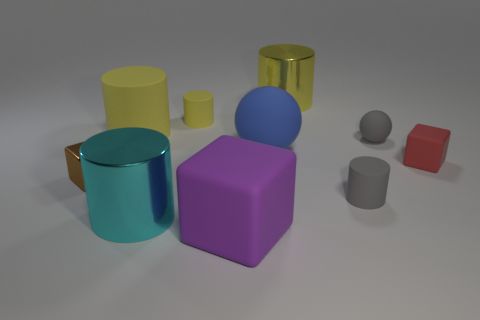Subtract all brown cubes. How many yellow cylinders are left? 3 Subtract all gray cylinders. How many cylinders are left? 4 Subtract all big matte cylinders. How many cylinders are left? 4 Subtract 2 cylinders. How many cylinders are left? 3 Subtract all blue cylinders. Subtract all brown balls. How many cylinders are left? 5 Subtract all spheres. How many objects are left? 8 Subtract all purple metallic blocks. Subtract all large cyan metallic cylinders. How many objects are left? 9 Add 7 tiny gray rubber cylinders. How many tiny gray rubber cylinders are left? 8 Add 6 green metallic objects. How many green metallic objects exist? 6 Subtract 0 cyan cubes. How many objects are left? 10 